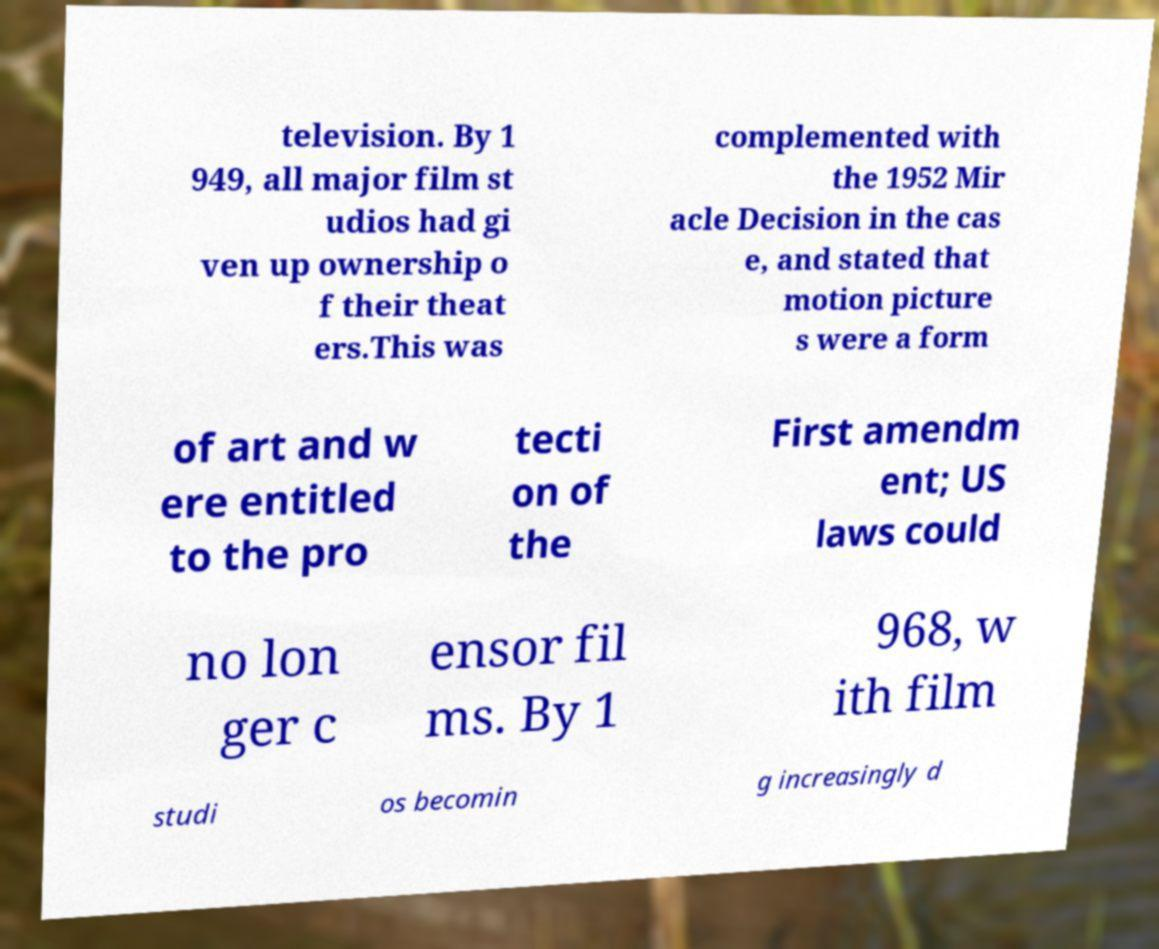Can you accurately transcribe the text from the provided image for me? television. By 1 949, all major film st udios had gi ven up ownership o f their theat ers.This was complemented with the 1952 Mir acle Decision in the cas e, and stated that motion picture s were a form of art and w ere entitled to the pro tecti on of the First amendm ent; US laws could no lon ger c ensor fil ms. By 1 968, w ith film studi os becomin g increasingly d 